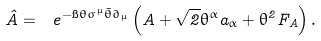<formula> <loc_0><loc_0><loc_500><loc_500>\hat { A } = \ e ^ { - \i \theta \sigma ^ { \mu } \bar { \theta } \partial _ { \mu } } \left ( A + \sqrt { 2 } \theta ^ { \alpha } a _ { \alpha } + \theta ^ { 2 } F _ { A } \right ) .</formula> 